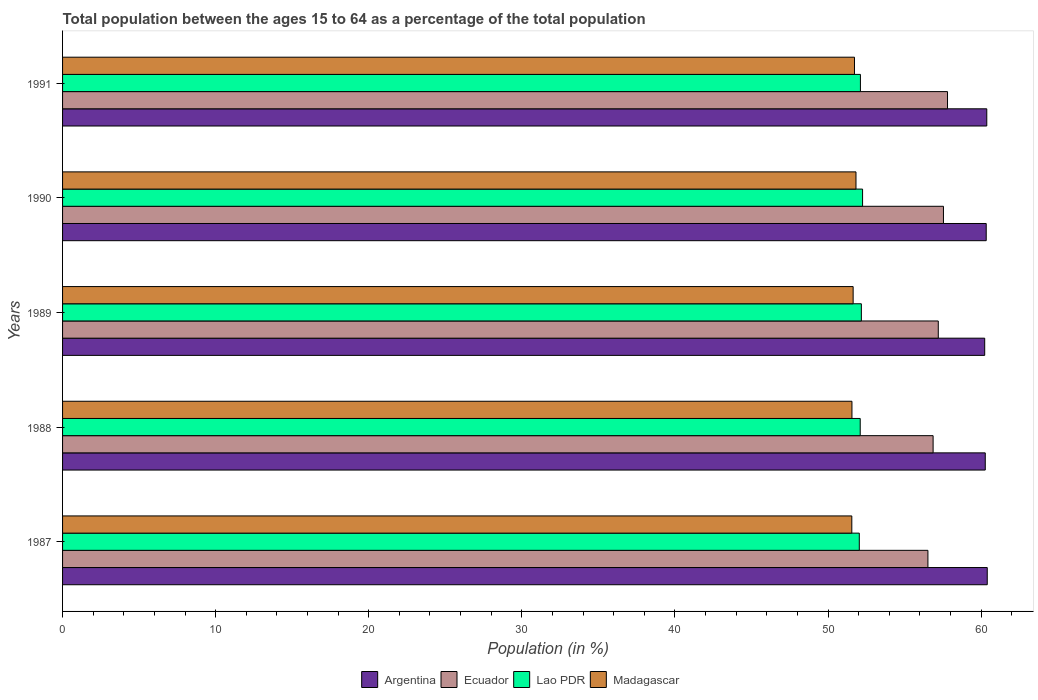How many different coloured bars are there?
Provide a succinct answer. 4. How many bars are there on the 2nd tick from the bottom?
Give a very brief answer. 4. What is the label of the 1st group of bars from the top?
Keep it short and to the point. 1991. In how many cases, is the number of bars for a given year not equal to the number of legend labels?
Make the answer very short. 0. What is the percentage of the population ages 15 to 64 in Ecuador in 1987?
Keep it short and to the point. 56.53. Across all years, what is the maximum percentage of the population ages 15 to 64 in Argentina?
Offer a terse response. 60.4. Across all years, what is the minimum percentage of the population ages 15 to 64 in Ecuador?
Offer a terse response. 56.53. In which year was the percentage of the population ages 15 to 64 in Lao PDR maximum?
Ensure brevity in your answer.  1990. In which year was the percentage of the population ages 15 to 64 in Ecuador minimum?
Keep it short and to the point. 1987. What is the total percentage of the population ages 15 to 64 in Ecuador in the graph?
Keep it short and to the point. 285.94. What is the difference between the percentage of the population ages 15 to 64 in Argentina in 1989 and that in 1991?
Offer a terse response. -0.14. What is the difference between the percentage of the population ages 15 to 64 in Lao PDR in 1987 and the percentage of the population ages 15 to 64 in Madagascar in 1988?
Keep it short and to the point. 0.48. What is the average percentage of the population ages 15 to 64 in Ecuador per year?
Give a very brief answer. 57.19. In the year 1990, what is the difference between the percentage of the population ages 15 to 64 in Argentina and percentage of the population ages 15 to 64 in Madagascar?
Your answer should be very brief. 8.51. What is the ratio of the percentage of the population ages 15 to 64 in Lao PDR in 1990 to that in 1991?
Offer a terse response. 1. Is the percentage of the population ages 15 to 64 in Lao PDR in 1988 less than that in 1989?
Offer a very short reply. Yes. Is the difference between the percentage of the population ages 15 to 64 in Argentina in 1988 and 1989 greater than the difference between the percentage of the population ages 15 to 64 in Madagascar in 1988 and 1989?
Ensure brevity in your answer.  Yes. What is the difference between the highest and the second highest percentage of the population ages 15 to 64 in Ecuador?
Offer a terse response. 0.26. What is the difference between the highest and the lowest percentage of the population ages 15 to 64 in Madagascar?
Your answer should be compact. 0.27. What does the 1st bar from the top in 1990 represents?
Keep it short and to the point. Madagascar. What does the 1st bar from the bottom in 1990 represents?
Keep it short and to the point. Argentina. Are all the bars in the graph horizontal?
Give a very brief answer. Yes. How many years are there in the graph?
Ensure brevity in your answer.  5. Does the graph contain any zero values?
Give a very brief answer. No. Where does the legend appear in the graph?
Provide a short and direct response. Bottom center. What is the title of the graph?
Offer a terse response. Total population between the ages 15 to 64 as a percentage of the total population. What is the label or title of the X-axis?
Offer a very short reply. Population (in %). What is the label or title of the Y-axis?
Your answer should be very brief. Years. What is the Population (in %) of Argentina in 1987?
Your answer should be very brief. 60.4. What is the Population (in %) of Ecuador in 1987?
Offer a very short reply. 56.53. What is the Population (in %) in Lao PDR in 1987?
Provide a succinct answer. 52.04. What is the Population (in %) of Madagascar in 1987?
Provide a short and direct response. 51.55. What is the Population (in %) in Argentina in 1988?
Your answer should be compact. 60.27. What is the Population (in %) of Ecuador in 1988?
Make the answer very short. 56.86. What is the Population (in %) in Lao PDR in 1988?
Make the answer very short. 52.1. What is the Population (in %) in Madagascar in 1988?
Make the answer very short. 51.56. What is the Population (in %) in Argentina in 1989?
Offer a very short reply. 60.23. What is the Population (in %) of Ecuador in 1989?
Ensure brevity in your answer.  57.2. What is the Population (in %) in Lao PDR in 1989?
Your answer should be compact. 52.18. What is the Population (in %) in Madagascar in 1989?
Offer a terse response. 51.64. What is the Population (in %) in Argentina in 1990?
Ensure brevity in your answer.  60.33. What is the Population (in %) in Ecuador in 1990?
Keep it short and to the point. 57.54. What is the Population (in %) in Lao PDR in 1990?
Your answer should be compact. 52.26. What is the Population (in %) in Madagascar in 1990?
Your answer should be very brief. 51.83. What is the Population (in %) in Argentina in 1991?
Your response must be concise. 60.37. What is the Population (in %) of Ecuador in 1991?
Make the answer very short. 57.81. What is the Population (in %) of Lao PDR in 1991?
Offer a terse response. 52.12. What is the Population (in %) in Madagascar in 1991?
Your response must be concise. 51.73. Across all years, what is the maximum Population (in %) of Argentina?
Ensure brevity in your answer.  60.4. Across all years, what is the maximum Population (in %) in Ecuador?
Your answer should be compact. 57.81. Across all years, what is the maximum Population (in %) of Lao PDR?
Your response must be concise. 52.26. Across all years, what is the maximum Population (in %) in Madagascar?
Your answer should be very brief. 51.83. Across all years, what is the minimum Population (in %) of Argentina?
Make the answer very short. 60.23. Across all years, what is the minimum Population (in %) of Ecuador?
Provide a short and direct response. 56.53. Across all years, what is the minimum Population (in %) in Lao PDR?
Offer a terse response. 52.04. Across all years, what is the minimum Population (in %) of Madagascar?
Ensure brevity in your answer.  51.55. What is the total Population (in %) of Argentina in the graph?
Offer a terse response. 301.61. What is the total Population (in %) in Ecuador in the graph?
Offer a very short reply. 285.94. What is the total Population (in %) of Lao PDR in the graph?
Your response must be concise. 260.7. What is the total Population (in %) of Madagascar in the graph?
Provide a succinct answer. 258.31. What is the difference between the Population (in %) in Argentina in 1987 and that in 1988?
Your answer should be compact. 0.13. What is the difference between the Population (in %) in Ecuador in 1987 and that in 1988?
Your answer should be very brief. -0.34. What is the difference between the Population (in %) in Lao PDR in 1987 and that in 1988?
Give a very brief answer. -0.06. What is the difference between the Population (in %) in Madagascar in 1987 and that in 1988?
Offer a terse response. -0.01. What is the difference between the Population (in %) in Argentina in 1987 and that in 1989?
Ensure brevity in your answer.  0.17. What is the difference between the Population (in %) in Ecuador in 1987 and that in 1989?
Ensure brevity in your answer.  -0.68. What is the difference between the Population (in %) of Lao PDR in 1987 and that in 1989?
Keep it short and to the point. -0.13. What is the difference between the Population (in %) in Madagascar in 1987 and that in 1989?
Provide a short and direct response. -0.09. What is the difference between the Population (in %) in Argentina in 1987 and that in 1990?
Offer a terse response. 0.07. What is the difference between the Population (in %) in Ecuador in 1987 and that in 1990?
Your answer should be very brief. -1.01. What is the difference between the Population (in %) in Lao PDR in 1987 and that in 1990?
Give a very brief answer. -0.21. What is the difference between the Population (in %) of Madagascar in 1987 and that in 1990?
Offer a very short reply. -0.27. What is the difference between the Population (in %) in Argentina in 1987 and that in 1991?
Your answer should be very brief. 0.03. What is the difference between the Population (in %) of Ecuador in 1987 and that in 1991?
Provide a succinct answer. -1.28. What is the difference between the Population (in %) of Lao PDR in 1987 and that in 1991?
Ensure brevity in your answer.  -0.07. What is the difference between the Population (in %) of Madagascar in 1987 and that in 1991?
Provide a short and direct response. -0.17. What is the difference between the Population (in %) of Argentina in 1988 and that in 1989?
Your answer should be very brief. 0.04. What is the difference between the Population (in %) of Ecuador in 1988 and that in 1989?
Give a very brief answer. -0.34. What is the difference between the Population (in %) of Lao PDR in 1988 and that in 1989?
Your answer should be compact. -0.07. What is the difference between the Population (in %) of Madagascar in 1988 and that in 1989?
Offer a terse response. -0.08. What is the difference between the Population (in %) of Argentina in 1988 and that in 1990?
Offer a terse response. -0.06. What is the difference between the Population (in %) of Ecuador in 1988 and that in 1990?
Make the answer very short. -0.68. What is the difference between the Population (in %) in Lao PDR in 1988 and that in 1990?
Give a very brief answer. -0.15. What is the difference between the Population (in %) in Madagascar in 1988 and that in 1990?
Make the answer very short. -0.26. What is the difference between the Population (in %) of Argentina in 1988 and that in 1991?
Your answer should be very brief. -0.1. What is the difference between the Population (in %) in Ecuador in 1988 and that in 1991?
Provide a short and direct response. -0.94. What is the difference between the Population (in %) of Lao PDR in 1988 and that in 1991?
Your response must be concise. -0.01. What is the difference between the Population (in %) in Madagascar in 1988 and that in 1991?
Your response must be concise. -0.17. What is the difference between the Population (in %) in Argentina in 1989 and that in 1990?
Make the answer very short. -0.1. What is the difference between the Population (in %) of Ecuador in 1989 and that in 1990?
Your response must be concise. -0.34. What is the difference between the Population (in %) in Lao PDR in 1989 and that in 1990?
Ensure brevity in your answer.  -0.08. What is the difference between the Population (in %) in Madagascar in 1989 and that in 1990?
Keep it short and to the point. -0.19. What is the difference between the Population (in %) in Argentina in 1989 and that in 1991?
Offer a very short reply. -0.14. What is the difference between the Population (in %) in Ecuador in 1989 and that in 1991?
Ensure brevity in your answer.  -0.6. What is the difference between the Population (in %) of Lao PDR in 1989 and that in 1991?
Provide a short and direct response. 0.06. What is the difference between the Population (in %) of Madagascar in 1989 and that in 1991?
Provide a succinct answer. -0.09. What is the difference between the Population (in %) in Argentina in 1990 and that in 1991?
Provide a short and direct response. -0.04. What is the difference between the Population (in %) of Ecuador in 1990 and that in 1991?
Provide a short and direct response. -0.26. What is the difference between the Population (in %) in Lao PDR in 1990 and that in 1991?
Ensure brevity in your answer.  0.14. What is the difference between the Population (in %) of Madagascar in 1990 and that in 1991?
Make the answer very short. 0.1. What is the difference between the Population (in %) in Argentina in 1987 and the Population (in %) in Ecuador in 1988?
Make the answer very short. 3.54. What is the difference between the Population (in %) in Argentina in 1987 and the Population (in %) in Lao PDR in 1988?
Your answer should be compact. 8.3. What is the difference between the Population (in %) of Argentina in 1987 and the Population (in %) of Madagascar in 1988?
Your answer should be compact. 8.84. What is the difference between the Population (in %) in Ecuador in 1987 and the Population (in %) in Lao PDR in 1988?
Provide a short and direct response. 4.42. What is the difference between the Population (in %) in Ecuador in 1987 and the Population (in %) in Madagascar in 1988?
Your answer should be very brief. 4.96. What is the difference between the Population (in %) in Lao PDR in 1987 and the Population (in %) in Madagascar in 1988?
Make the answer very short. 0.48. What is the difference between the Population (in %) of Argentina in 1987 and the Population (in %) of Ecuador in 1989?
Provide a short and direct response. 3.2. What is the difference between the Population (in %) of Argentina in 1987 and the Population (in %) of Lao PDR in 1989?
Offer a terse response. 8.22. What is the difference between the Population (in %) of Argentina in 1987 and the Population (in %) of Madagascar in 1989?
Your answer should be very brief. 8.76. What is the difference between the Population (in %) of Ecuador in 1987 and the Population (in %) of Lao PDR in 1989?
Keep it short and to the point. 4.35. What is the difference between the Population (in %) in Ecuador in 1987 and the Population (in %) in Madagascar in 1989?
Offer a terse response. 4.88. What is the difference between the Population (in %) of Lao PDR in 1987 and the Population (in %) of Madagascar in 1989?
Your response must be concise. 0.4. What is the difference between the Population (in %) in Argentina in 1987 and the Population (in %) in Ecuador in 1990?
Provide a short and direct response. 2.86. What is the difference between the Population (in %) of Argentina in 1987 and the Population (in %) of Lao PDR in 1990?
Keep it short and to the point. 8.14. What is the difference between the Population (in %) in Argentina in 1987 and the Population (in %) in Madagascar in 1990?
Your answer should be very brief. 8.57. What is the difference between the Population (in %) in Ecuador in 1987 and the Population (in %) in Lao PDR in 1990?
Your answer should be compact. 4.27. What is the difference between the Population (in %) of Ecuador in 1987 and the Population (in %) of Madagascar in 1990?
Ensure brevity in your answer.  4.7. What is the difference between the Population (in %) in Lao PDR in 1987 and the Population (in %) in Madagascar in 1990?
Make the answer very short. 0.22. What is the difference between the Population (in %) of Argentina in 1987 and the Population (in %) of Ecuador in 1991?
Offer a terse response. 2.6. What is the difference between the Population (in %) of Argentina in 1987 and the Population (in %) of Lao PDR in 1991?
Offer a very short reply. 8.28. What is the difference between the Population (in %) in Argentina in 1987 and the Population (in %) in Madagascar in 1991?
Keep it short and to the point. 8.67. What is the difference between the Population (in %) of Ecuador in 1987 and the Population (in %) of Lao PDR in 1991?
Your response must be concise. 4.41. What is the difference between the Population (in %) in Ecuador in 1987 and the Population (in %) in Madagascar in 1991?
Ensure brevity in your answer.  4.8. What is the difference between the Population (in %) in Lao PDR in 1987 and the Population (in %) in Madagascar in 1991?
Your answer should be compact. 0.31. What is the difference between the Population (in %) of Argentina in 1988 and the Population (in %) of Ecuador in 1989?
Your answer should be compact. 3.07. What is the difference between the Population (in %) in Argentina in 1988 and the Population (in %) in Lao PDR in 1989?
Make the answer very short. 8.09. What is the difference between the Population (in %) of Argentina in 1988 and the Population (in %) of Madagascar in 1989?
Offer a terse response. 8.63. What is the difference between the Population (in %) in Ecuador in 1988 and the Population (in %) in Lao PDR in 1989?
Provide a succinct answer. 4.69. What is the difference between the Population (in %) of Ecuador in 1988 and the Population (in %) of Madagascar in 1989?
Provide a succinct answer. 5.22. What is the difference between the Population (in %) in Lao PDR in 1988 and the Population (in %) in Madagascar in 1989?
Offer a terse response. 0.46. What is the difference between the Population (in %) in Argentina in 1988 and the Population (in %) in Ecuador in 1990?
Keep it short and to the point. 2.73. What is the difference between the Population (in %) of Argentina in 1988 and the Population (in %) of Lao PDR in 1990?
Offer a very short reply. 8.01. What is the difference between the Population (in %) of Argentina in 1988 and the Population (in %) of Madagascar in 1990?
Your response must be concise. 8.44. What is the difference between the Population (in %) of Ecuador in 1988 and the Population (in %) of Lao PDR in 1990?
Offer a very short reply. 4.61. What is the difference between the Population (in %) of Ecuador in 1988 and the Population (in %) of Madagascar in 1990?
Give a very brief answer. 5.04. What is the difference between the Population (in %) in Lao PDR in 1988 and the Population (in %) in Madagascar in 1990?
Offer a terse response. 0.28. What is the difference between the Population (in %) in Argentina in 1988 and the Population (in %) in Ecuador in 1991?
Provide a succinct answer. 2.47. What is the difference between the Population (in %) of Argentina in 1988 and the Population (in %) of Lao PDR in 1991?
Offer a very short reply. 8.15. What is the difference between the Population (in %) in Argentina in 1988 and the Population (in %) in Madagascar in 1991?
Provide a short and direct response. 8.54. What is the difference between the Population (in %) of Ecuador in 1988 and the Population (in %) of Lao PDR in 1991?
Keep it short and to the point. 4.75. What is the difference between the Population (in %) of Ecuador in 1988 and the Population (in %) of Madagascar in 1991?
Offer a very short reply. 5.13. What is the difference between the Population (in %) of Lao PDR in 1988 and the Population (in %) of Madagascar in 1991?
Make the answer very short. 0.37. What is the difference between the Population (in %) in Argentina in 1989 and the Population (in %) in Ecuador in 1990?
Provide a short and direct response. 2.69. What is the difference between the Population (in %) in Argentina in 1989 and the Population (in %) in Lao PDR in 1990?
Give a very brief answer. 7.98. What is the difference between the Population (in %) in Argentina in 1989 and the Population (in %) in Madagascar in 1990?
Your answer should be very brief. 8.41. What is the difference between the Population (in %) in Ecuador in 1989 and the Population (in %) in Lao PDR in 1990?
Ensure brevity in your answer.  4.95. What is the difference between the Population (in %) in Ecuador in 1989 and the Population (in %) in Madagascar in 1990?
Make the answer very short. 5.38. What is the difference between the Population (in %) of Lao PDR in 1989 and the Population (in %) of Madagascar in 1990?
Your answer should be compact. 0.35. What is the difference between the Population (in %) in Argentina in 1989 and the Population (in %) in Ecuador in 1991?
Make the answer very short. 2.43. What is the difference between the Population (in %) of Argentina in 1989 and the Population (in %) of Lao PDR in 1991?
Keep it short and to the point. 8.12. What is the difference between the Population (in %) in Argentina in 1989 and the Population (in %) in Madagascar in 1991?
Your answer should be compact. 8.51. What is the difference between the Population (in %) of Ecuador in 1989 and the Population (in %) of Lao PDR in 1991?
Provide a succinct answer. 5.09. What is the difference between the Population (in %) in Ecuador in 1989 and the Population (in %) in Madagascar in 1991?
Ensure brevity in your answer.  5.47. What is the difference between the Population (in %) of Lao PDR in 1989 and the Population (in %) of Madagascar in 1991?
Offer a very short reply. 0.45. What is the difference between the Population (in %) of Argentina in 1990 and the Population (in %) of Ecuador in 1991?
Give a very brief answer. 2.53. What is the difference between the Population (in %) in Argentina in 1990 and the Population (in %) in Lao PDR in 1991?
Your answer should be very brief. 8.22. What is the difference between the Population (in %) of Argentina in 1990 and the Population (in %) of Madagascar in 1991?
Provide a succinct answer. 8.6. What is the difference between the Population (in %) of Ecuador in 1990 and the Population (in %) of Lao PDR in 1991?
Your response must be concise. 5.42. What is the difference between the Population (in %) in Ecuador in 1990 and the Population (in %) in Madagascar in 1991?
Your response must be concise. 5.81. What is the difference between the Population (in %) in Lao PDR in 1990 and the Population (in %) in Madagascar in 1991?
Make the answer very short. 0.53. What is the average Population (in %) in Argentina per year?
Give a very brief answer. 60.32. What is the average Population (in %) of Ecuador per year?
Ensure brevity in your answer.  57.19. What is the average Population (in %) in Lao PDR per year?
Ensure brevity in your answer.  52.14. What is the average Population (in %) in Madagascar per year?
Ensure brevity in your answer.  51.66. In the year 1987, what is the difference between the Population (in %) in Argentina and Population (in %) in Ecuador?
Offer a terse response. 3.88. In the year 1987, what is the difference between the Population (in %) of Argentina and Population (in %) of Lao PDR?
Your answer should be compact. 8.36. In the year 1987, what is the difference between the Population (in %) in Argentina and Population (in %) in Madagascar?
Make the answer very short. 8.85. In the year 1987, what is the difference between the Population (in %) in Ecuador and Population (in %) in Lao PDR?
Ensure brevity in your answer.  4.48. In the year 1987, what is the difference between the Population (in %) in Ecuador and Population (in %) in Madagascar?
Make the answer very short. 4.97. In the year 1987, what is the difference between the Population (in %) of Lao PDR and Population (in %) of Madagascar?
Provide a short and direct response. 0.49. In the year 1988, what is the difference between the Population (in %) in Argentina and Population (in %) in Ecuador?
Keep it short and to the point. 3.41. In the year 1988, what is the difference between the Population (in %) in Argentina and Population (in %) in Lao PDR?
Provide a short and direct response. 8.17. In the year 1988, what is the difference between the Population (in %) of Argentina and Population (in %) of Madagascar?
Give a very brief answer. 8.71. In the year 1988, what is the difference between the Population (in %) in Ecuador and Population (in %) in Lao PDR?
Give a very brief answer. 4.76. In the year 1988, what is the difference between the Population (in %) in Ecuador and Population (in %) in Madagascar?
Ensure brevity in your answer.  5.3. In the year 1988, what is the difference between the Population (in %) of Lao PDR and Population (in %) of Madagascar?
Ensure brevity in your answer.  0.54. In the year 1989, what is the difference between the Population (in %) of Argentina and Population (in %) of Ecuador?
Make the answer very short. 3.03. In the year 1989, what is the difference between the Population (in %) of Argentina and Population (in %) of Lao PDR?
Give a very brief answer. 8.06. In the year 1989, what is the difference between the Population (in %) in Argentina and Population (in %) in Madagascar?
Provide a short and direct response. 8.59. In the year 1989, what is the difference between the Population (in %) in Ecuador and Population (in %) in Lao PDR?
Offer a terse response. 5.03. In the year 1989, what is the difference between the Population (in %) in Ecuador and Population (in %) in Madagascar?
Ensure brevity in your answer.  5.56. In the year 1989, what is the difference between the Population (in %) of Lao PDR and Population (in %) of Madagascar?
Your response must be concise. 0.54. In the year 1990, what is the difference between the Population (in %) in Argentina and Population (in %) in Ecuador?
Your response must be concise. 2.79. In the year 1990, what is the difference between the Population (in %) in Argentina and Population (in %) in Lao PDR?
Ensure brevity in your answer.  8.08. In the year 1990, what is the difference between the Population (in %) of Argentina and Population (in %) of Madagascar?
Keep it short and to the point. 8.51. In the year 1990, what is the difference between the Population (in %) of Ecuador and Population (in %) of Lao PDR?
Make the answer very short. 5.28. In the year 1990, what is the difference between the Population (in %) of Ecuador and Population (in %) of Madagascar?
Provide a short and direct response. 5.71. In the year 1990, what is the difference between the Population (in %) of Lao PDR and Population (in %) of Madagascar?
Your answer should be compact. 0.43. In the year 1991, what is the difference between the Population (in %) of Argentina and Population (in %) of Ecuador?
Ensure brevity in your answer.  2.56. In the year 1991, what is the difference between the Population (in %) of Argentina and Population (in %) of Lao PDR?
Ensure brevity in your answer.  8.25. In the year 1991, what is the difference between the Population (in %) of Argentina and Population (in %) of Madagascar?
Provide a succinct answer. 8.64. In the year 1991, what is the difference between the Population (in %) in Ecuador and Population (in %) in Lao PDR?
Offer a terse response. 5.69. In the year 1991, what is the difference between the Population (in %) of Ecuador and Population (in %) of Madagascar?
Your answer should be compact. 6.08. In the year 1991, what is the difference between the Population (in %) in Lao PDR and Population (in %) in Madagascar?
Ensure brevity in your answer.  0.39. What is the ratio of the Population (in %) in Lao PDR in 1987 to that in 1989?
Provide a succinct answer. 1. What is the ratio of the Population (in %) in Madagascar in 1987 to that in 1989?
Ensure brevity in your answer.  1. What is the ratio of the Population (in %) in Ecuador in 1987 to that in 1990?
Your response must be concise. 0.98. What is the ratio of the Population (in %) of Lao PDR in 1987 to that in 1990?
Provide a short and direct response. 1. What is the ratio of the Population (in %) of Ecuador in 1987 to that in 1991?
Offer a terse response. 0.98. What is the ratio of the Population (in %) of Argentina in 1988 to that in 1989?
Your response must be concise. 1. What is the ratio of the Population (in %) of Ecuador in 1988 to that in 1990?
Offer a terse response. 0.99. What is the ratio of the Population (in %) in Ecuador in 1988 to that in 1991?
Keep it short and to the point. 0.98. What is the ratio of the Population (in %) of Lao PDR in 1988 to that in 1991?
Give a very brief answer. 1. What is the ratio of the Population (in %) in Madagascar in 1988 to that in 1991?
Give a very brief answer. 1. What is the ratio of the Population (in %) of Ecuador in 1989 to that in 1990?
Your answer should be very brief. 0.99. What is the ratio of the Population (in %) of Lao PDR in 1989 to that in 1991?
Provide a short and direct response. 1. What is the ratio of the Population (in %) of Lao PDR in 1990 to that in 1991?
Keep it short and to the point. 1. What is the difference between the highest and the second highest Population (in %) in Argentina?
Your answer should be compact. 0.03. What is the difference between the highest and the second highest Population (in %) of Ecuador?
Offer a very short reply. 0.26. What is the difference between the highest and the second highest Population (in %) of Lao PDR?
Your answer should be very brief. 0.08. What is the difference between the highest and the second highest Population (in %) in Madagascar?
Your answer should be very brief. 0.1. What is the difference between the highest and the lowest Population (in %) of Argentina?
Provide a succinct answer. 0.17. What is the difference between the highest and the lowest Population (in %) of Ecuador?
Provide a succinct answer. 1.28. What is the difference between the highest and the lowest Population (in %) of Lao PDR?
Offer a very short reply. 0.21. What is the difference between the highest and the lowest Population (in %) of Madagascar?
Your answer should be very brief. 0.27. 